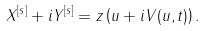<formula> <loc_0><loc_0><loc_500><loc_500>X ^ { [ s ] } + i Y ^ { [ s ] } = z \left ( u + i V ( u , t ) \right ) .</formula> 